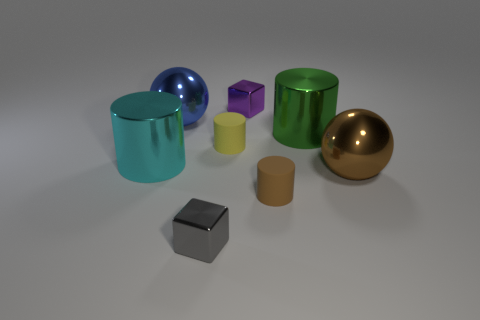Based on their appearances, which objects could be considered most similar to each other? The two cyan cylinders and the two golden spheres can be considered most similar to each other, owing to their identical shapes and color schemes. This similarity could suggest a sort of visual or thematic pairing within the composition of the image. 